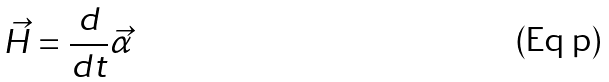Convert formula to latex. <formula><loc_0><loc_0><loc_500><loc_500>\vec { H } = \frac { d } { d t } \vec { \alpha }</formula> 